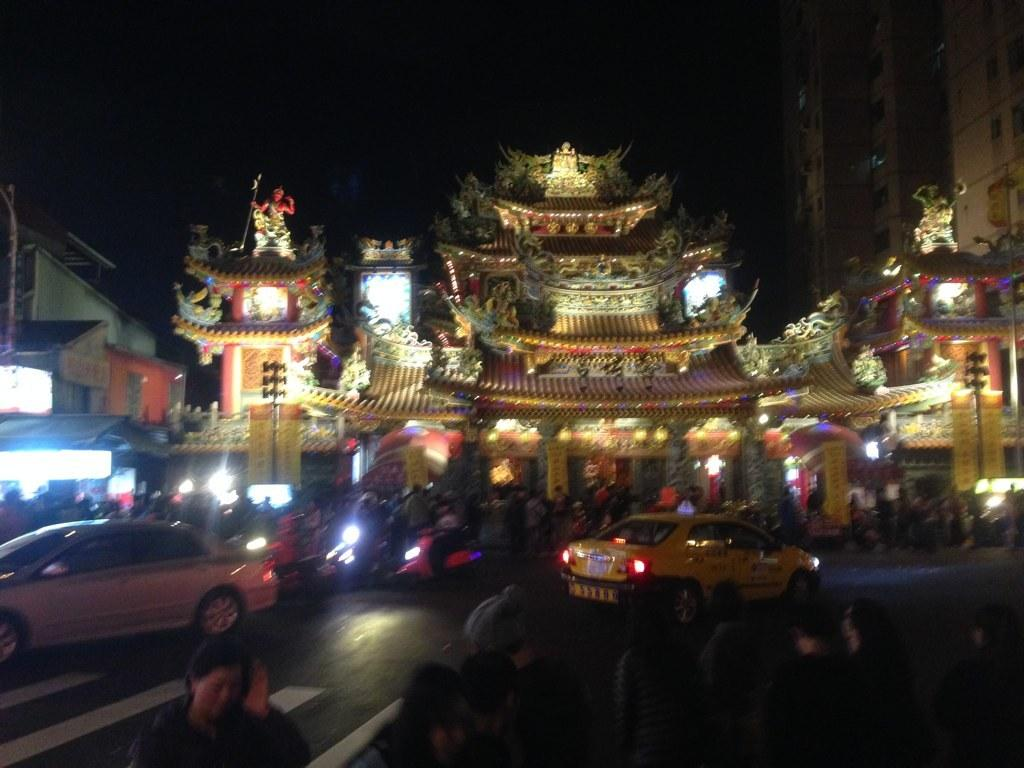Who or what can be seen in the image? There are people, vehicles, and buildings in the image. What else is present in the image? There are lights in the image. What is the color of the background in the image? The background of the image is dark. What type of coat is the uncle wearing in the image? There is no uncle or coat present in the image. What kind of club can be seen in the image? There is no club present in the image. 